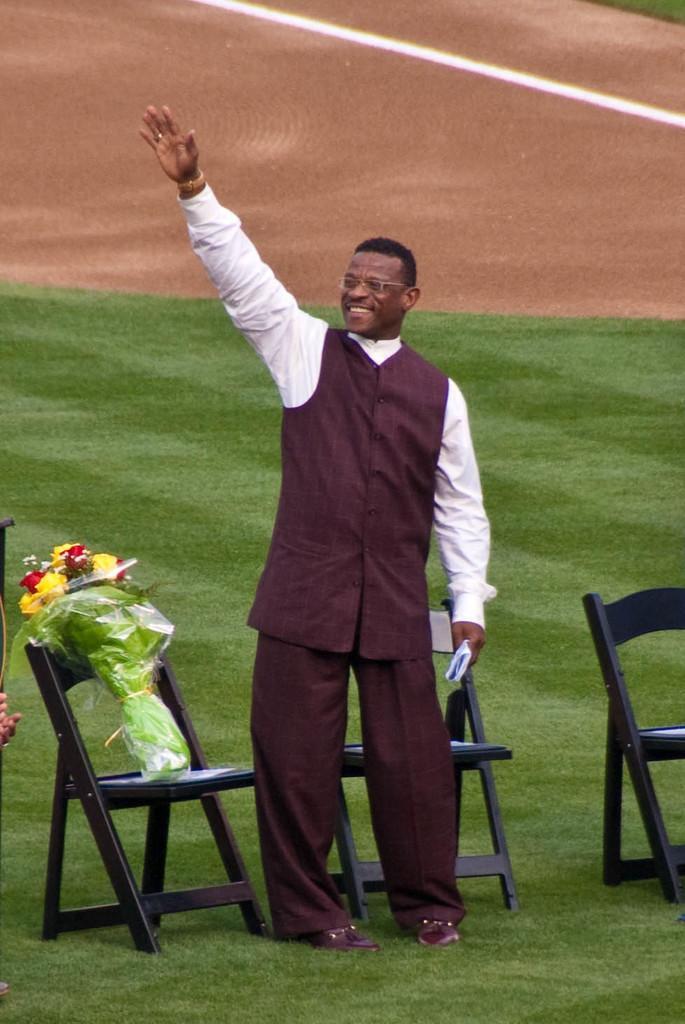What is the person in the image doing? The person is standing on the ground and waving their hand. What is the person holding in the image? The person is holding a napkin. What other objects can be seen in the image? There are chairs and a bouquet visible in the image. What type of surprise is the person about to reveal from the gold volcano in the image? There is no gold volcano or surprise present in the image. 